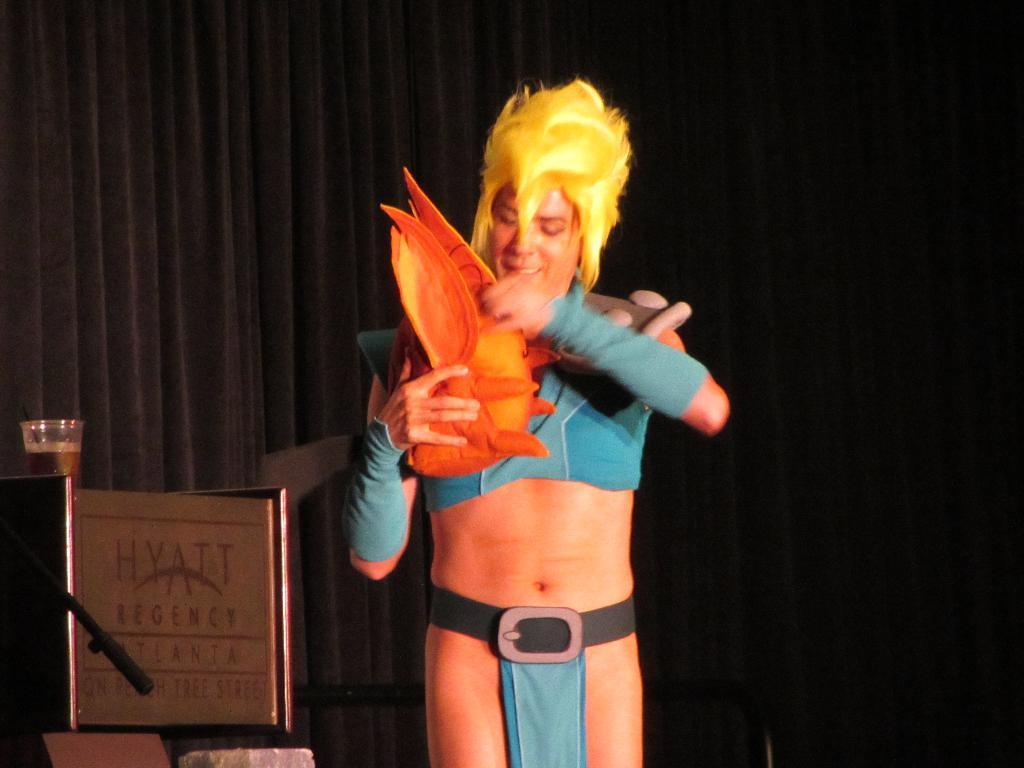How would you summarize this image in a sentence or two? In the center of the picture there is a person standing. On the left there is a glass and there are other objects. In the background it is curtain. 